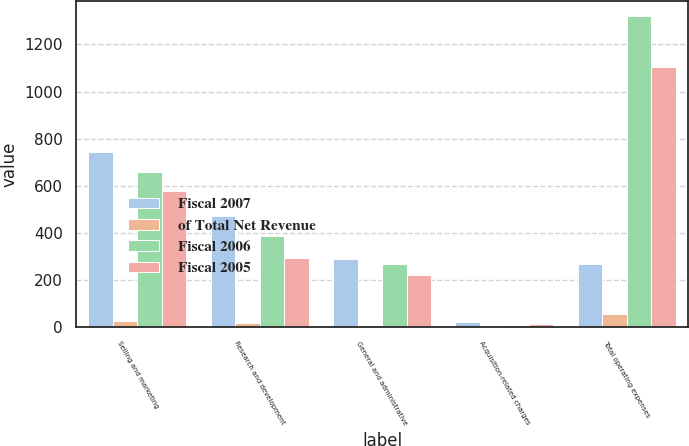Convert chart to OTSL. <chart><loc_0><loc_0><loc_500><loc_500><stacked_bar_chart><ecel><fcel>Selling and marketing<fcel>Research and development<fcel>General and administrative<fcel>Acquisition-related charges<fcel>Total operating expenses<nl><fcel>Fiscal 2007<fcel>742.4<fcel>472.5<fcel>291.1<fcel>20<fcel>267.2<nl><fcel>of Total Net Revenue<fcel>28<fcel>17<fcel>11<fcel>1<fcel>57<nl><fcel>Fiscal 2006<fcel>657.6<fcel>385.8<fcel>267.2<fcel>9.5<fcel>1320.1<nl><fcel>Fiscal 2005<fcel>576.8<fcel>292.6<fcel>222.6<fcel>12.7<fcel>1104.7<nl></chart> 